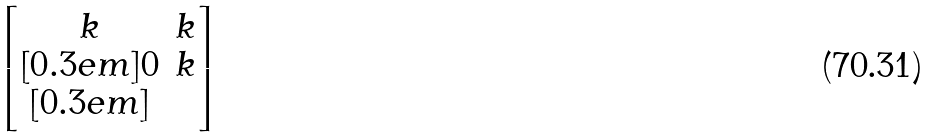Convert formula to latex. <formula><loc_0><loc_0><loc_500><loc_500>\begin{bmatrix} k & k \\ [ 0 . 3 e m ] 0 & k \\ [ 0 . 3 e m ] \end{bmatrix}</formula> 